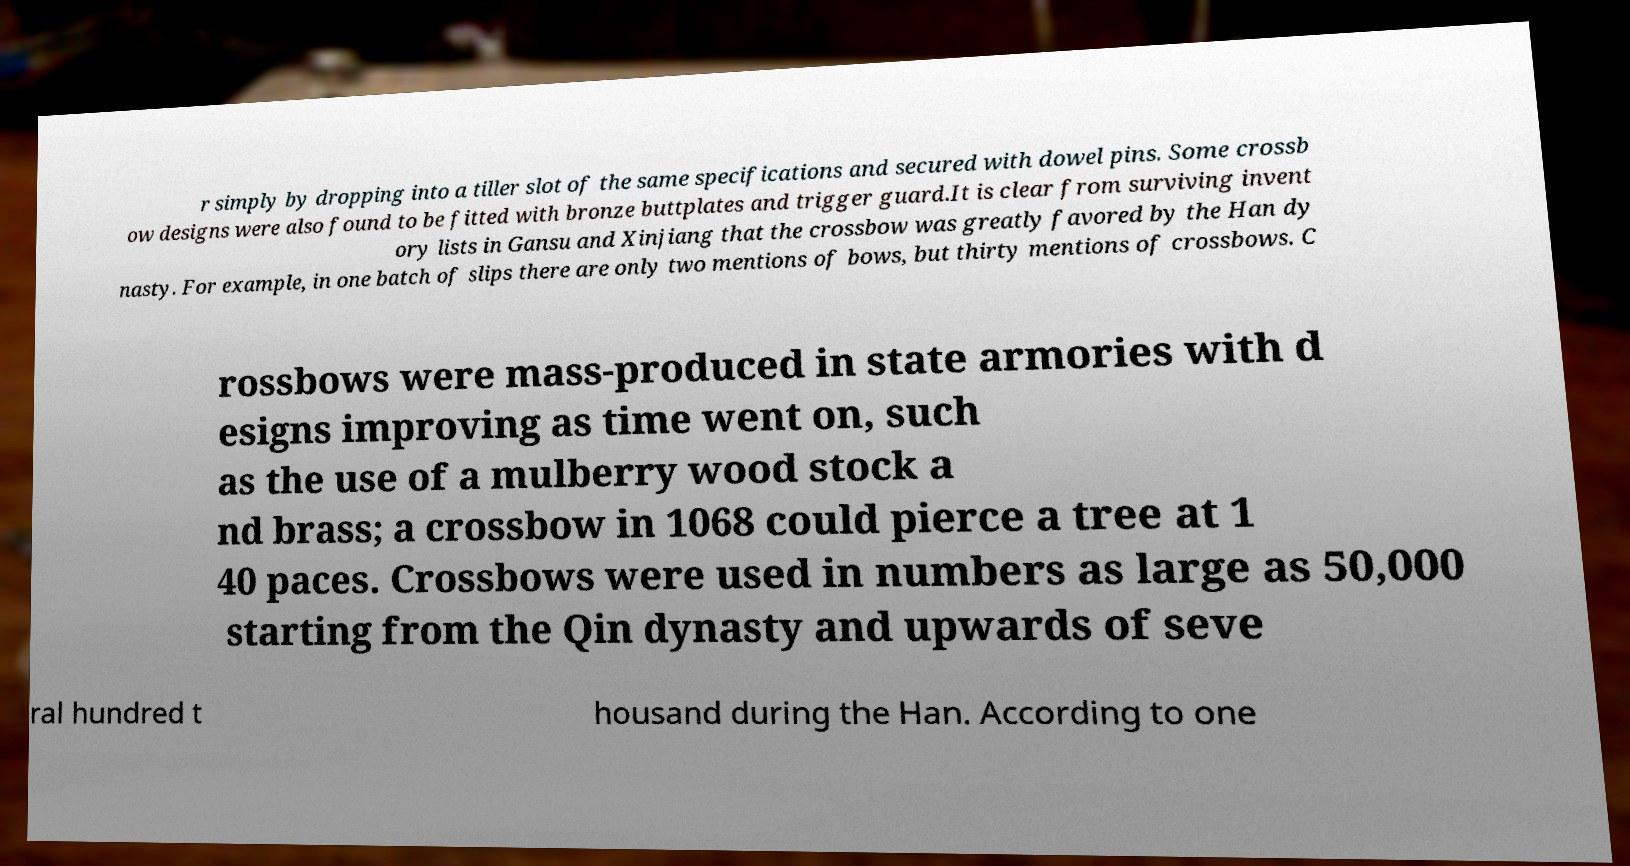There's text embedded in this image that I need extracted. Can you transcribe it verbatim? r simply by dropping into a tiller slot of the same specifications and secured with dowel pins. Some crossb ow designs were also found to be fitted with bronze buttplates and trigger guard.It is clear from surviving invent ory lists in Gansu and Xinjiang that the crossbow was greatly favored by the Han dy nasty. For example, in one batch of slips there are only two mentions of bows, but thirty mentions of crossbows. C rossbows were mass-produced in state armories with d esigns improving as time went on, such as the use of a mulberry wood stock a nd brass; a crossbow in 1068 could pierce a tree at 1 40 paces. Crossbows were used in numbers as large as 50,000 starting from the Qin dynasty and upwards of seve ral hundred t housand during the Han. According to one 